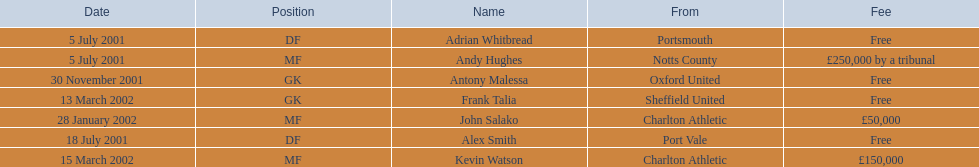Who were all the players? Andy Hughes, Adrian Whitbread, Alex Smith, Antony Malessa, John Salako, Frank Talia, Kevin Watson. What were the transfer fees of these players? £250,000 by a tribunal, Free, Free, Free, £50,000, Free, £150,000. Of these, which belong to andy hughes and john salako? £250,000 by a tribunal, £50,000. Of these, which is larger? £250,000 by a tribunal. Which player commanded this fee? Andy Hughes. 